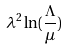<formula> <loc_0><loc_0><loc_500><loc_500>\lambda ^ { 2 } \ln ( \frac { \Lambda } { \mu } )</formula> 